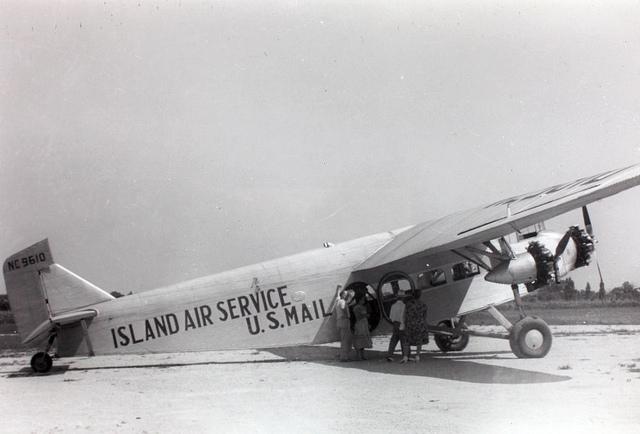What vehicle is this?
Write a very short answer. Airplane. What is written on the plane?
Quick response, please. Island air service us mail. How many people are shown here?
Keep it brief. 4. 